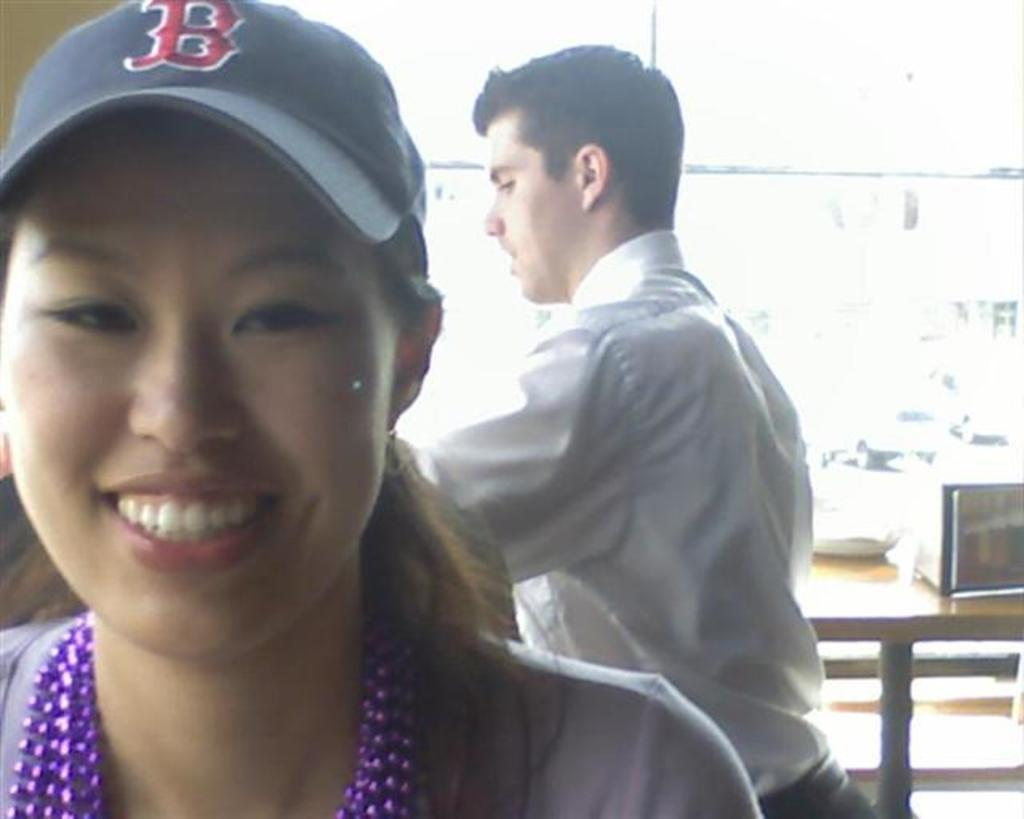Provide a one-sentence caption for the provided image. A woman is wearing a blue baseball cap with a red letter B. 